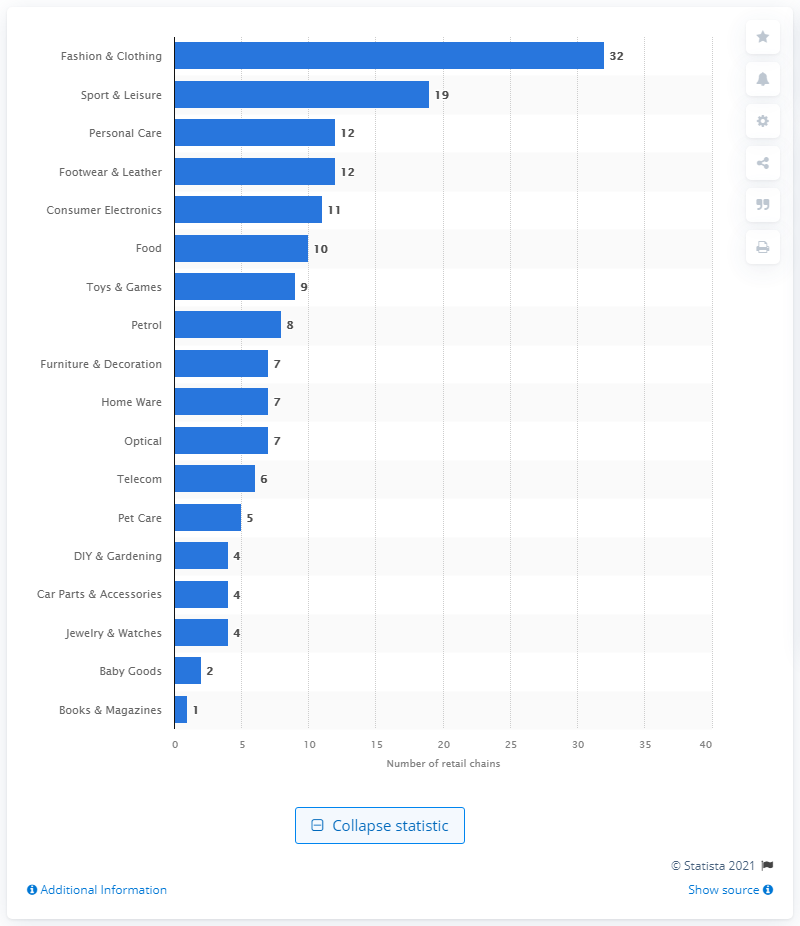List a handful of essential elements in this visual. In 2021, a total of 19 different sectors of the Hungarian economy were covered by retail chains. There were 12 retail chains in Hungary in 2021. 